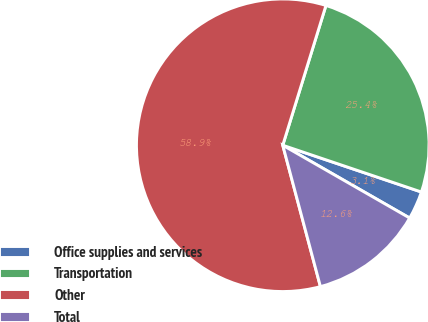Convert chart. <chart><loc_0><loc_0><loc_500><loc_500><pie_chart><fcel>Office supplies and services<fcel>Transportation<fcel>Other<fcel>Total<nl><fcel>3.11%<fcel>25.41%<fcel>58.92%<fcel>12.57%<nl></chart> 